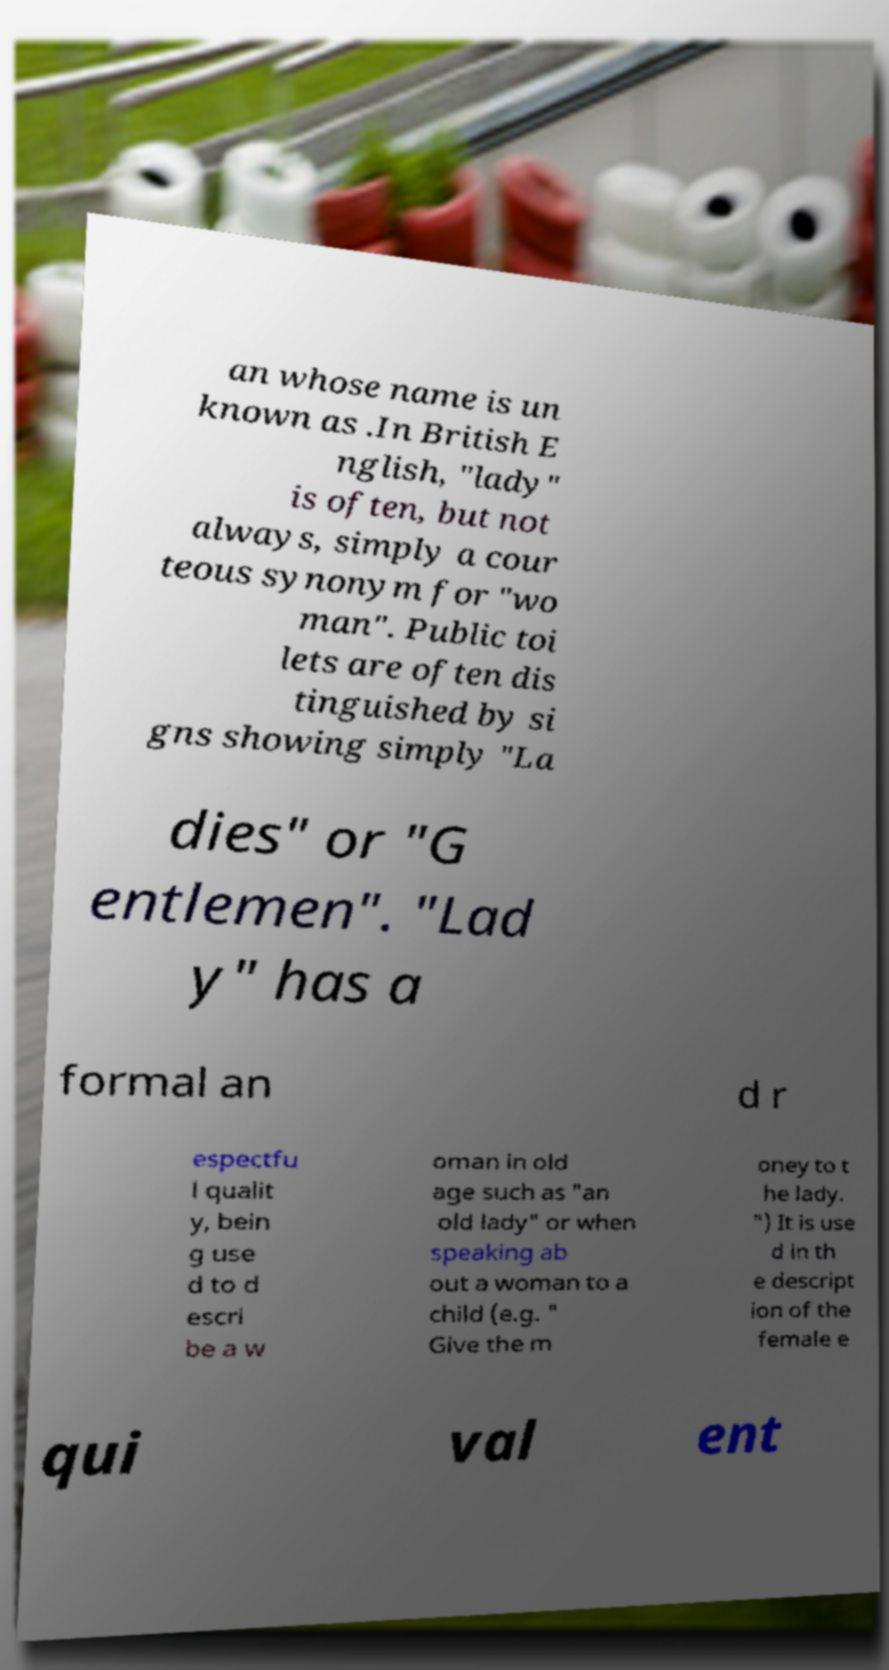For documentation purposes, I need the text within this image transcribed. Could you provide that? an whose name is un known as .In British E nglish, "lady" is often, but not always, simply a cour teous synonym for "wo man". Public toi lets are often dis tinguished by si gns showing simply "La dies" or "G entlemen". "Lad y" has a formal an d r espectfu l qualit y, bein g use d to d escri be a w oman in old age such as "an old lady" or when speaking ab out a woman to a child (e.g. " Give the m oney to t he lady. ") It is use d in th e descript ion of the female e qui val ent 